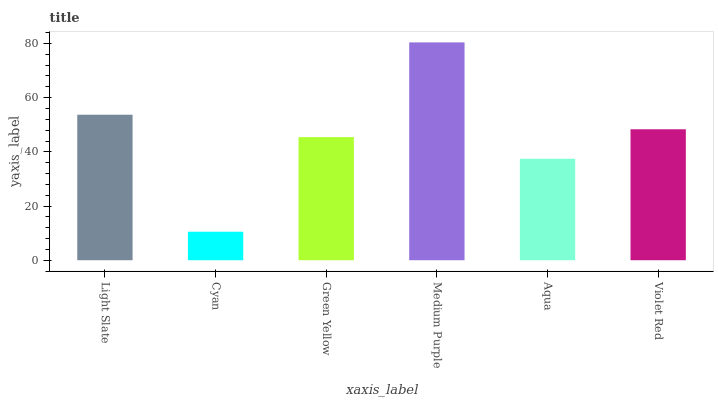Is Cyan the minimum?
Answer yes or no. Yes. Is Medium Purple the maximum?
Answer yes or no. Yes. Is Green Yellow the minimum?
Answer yes or no. No. Is Green Yellow the maximum?
Answer yes or no. No. Is Green Yellow greater than Cyan?
Answer yes or no. Yes. Is Cyan less than Green Yellow?
Answer yes or no. Yes. Is Cyan greater than Green Yellow?
Answer yes or no. No. Is Green Yellow less than Cyan?
Answer yes or no. No. Is Violet Red the high median?
Answer yes or no. Yes. Is Green Yellow the low median?
Answer yes or no. Yes. Is Green Yellow the high median?
Answer yes or no. No. Is Violet Red the low median?
Answer yes or no. No. 